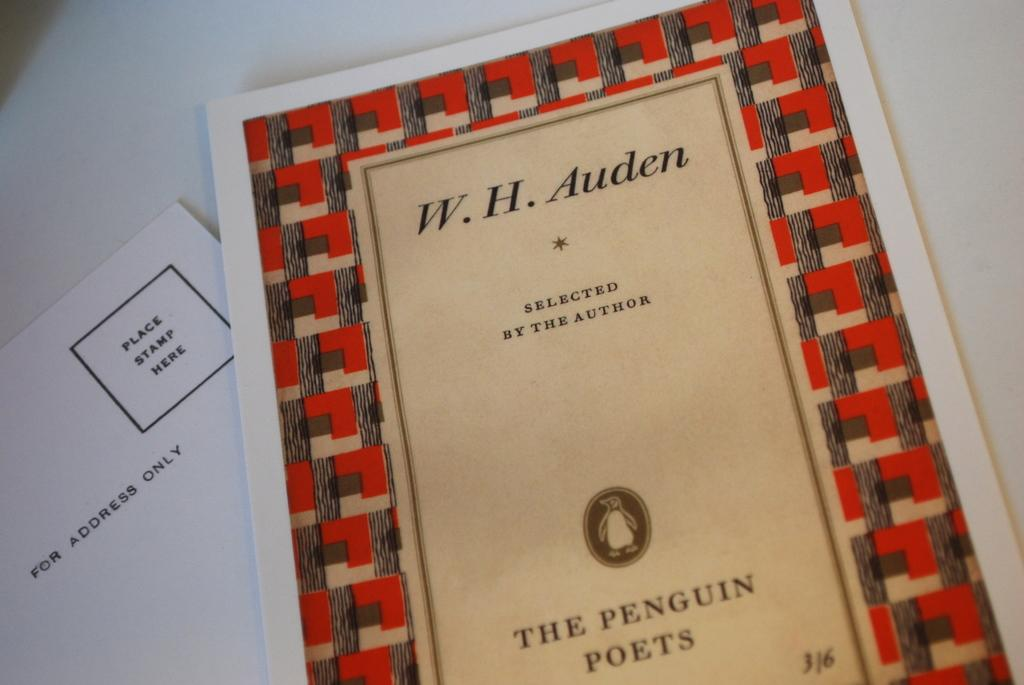Provide a one-sentence caption for the provided image. A book of poems selected by author W.H. Auden. 